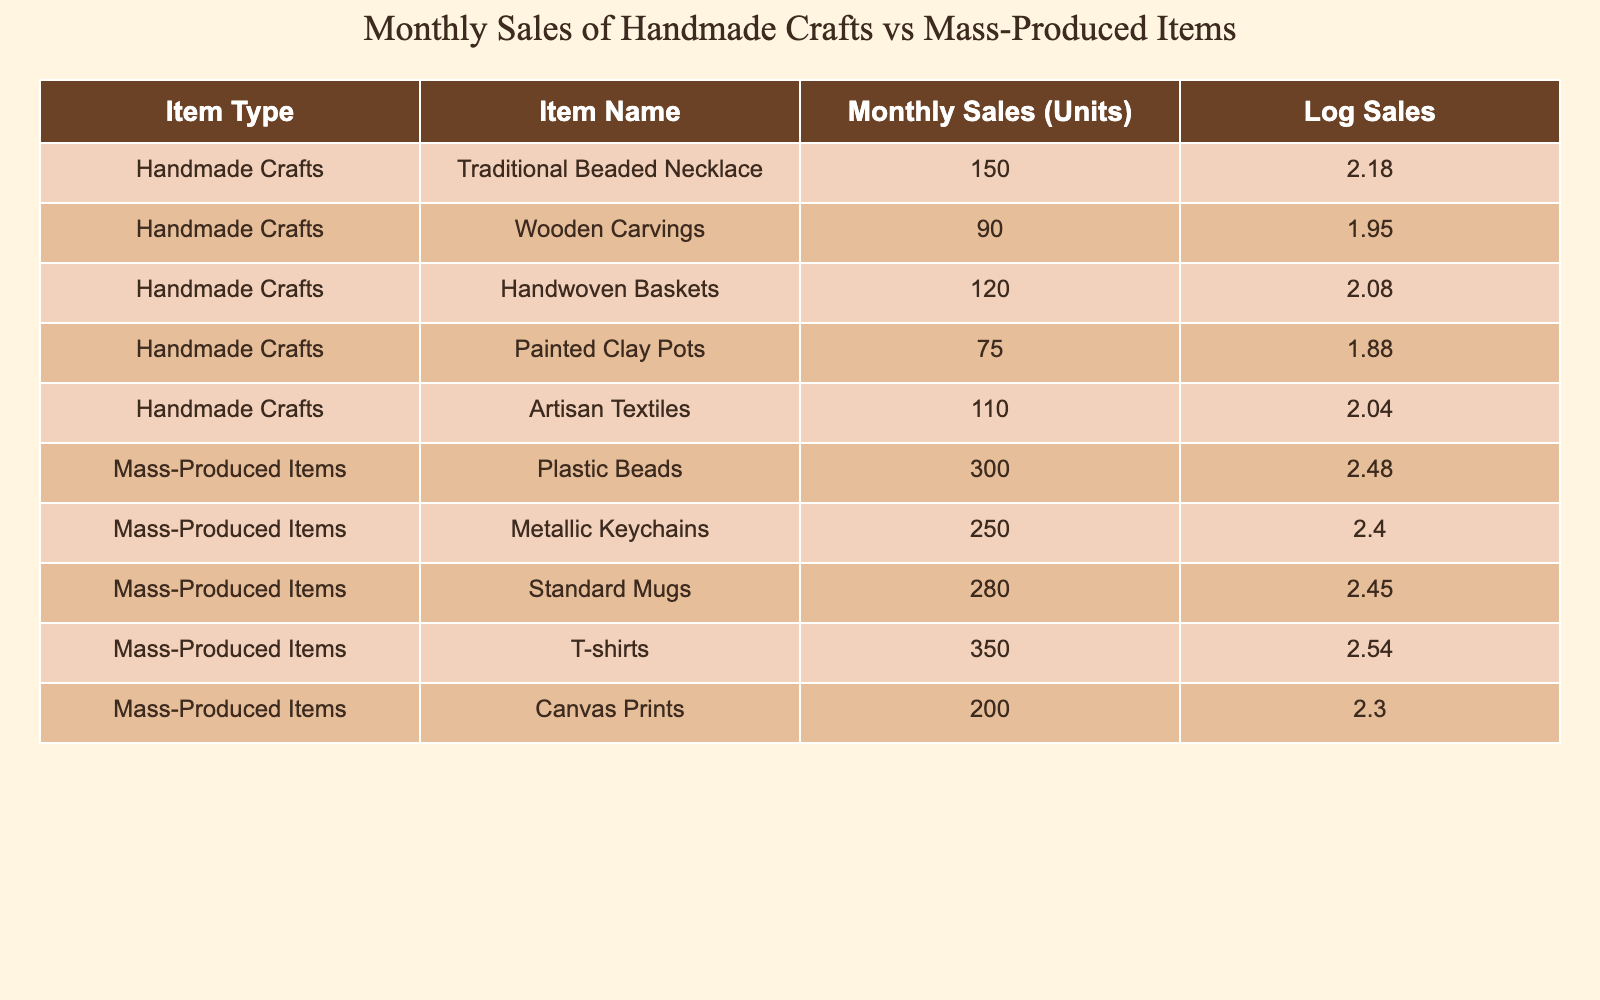What is the monthly sales (units) of the Painted Clay Pots? The table clearly lists the monthly sales for each item. For the Painted Clay Pots, the value is directly shown as 75 in the "Monthly Sales (Units)" column.
Answer: 75 Which item type has the highest monthly sales? To determine the highest sales, we need to compare the total monthly sales for both item types. The handmade crafts sum to 150 + 90 + 120 + 75 + 110 = 545, while mass-produced items sum to 300 + 250 + 280 + 350 + 200 = 1380. Since 1380 (mass-produced items) is greater than 545 (handmade crafts), mass-produced items have the highest sales.
Answer: Mass-produced items What is the difference in monthly sales between the top mass-produced item and the top handmade craft? The top-selling mass-produced item is T-shirts with 350 units, while the top-selling handmade craft is Traditional Beaded Necklace with 150 units. The difference is calculated as 350 - 150 = 200.
Answer: 200 Are more units sold of the Wooden Carvings than the Painted Clay Pots? The monthly sales for Wooden Carvings are 90 units, while for Painted Clay Pots, it is 75 units. Since 90 is greater than 75, it is true that more units of Wooden Carvings are sold.
Answer: Yes What is the average monthly sales of all handmade crafts? To find the average sales of handmade crafts, we first sum their sales: 150 + 90 + 120 + 75 + 110 = 545. Since there are 5 items, the average is 545 / 5 = 109. The average monthly sales for handmade crafts is then 109.
Answer: 109 Which has a higher log sales value, the T-shirts or the Traditional Beaded Necklace? The log sales for T-shirts is calculated as log10(350) which is approximately 2.54, while for Traditional Beaded Necklace it is log10(150) approximately 2.18. Since 2.54 is greater than 2.18, T-shirts have a higher log sales value.
Answer: T-shirts What is the combined monthly sales of all mass-produced items? To calculate the combined sales of mass-produced items, sum all their respective sales: 300 + 250 + 280 + 350 + 200 = 1380. Hence, the combined monthly sales is 1380 units.
Answer: 1380 Is the monthly sales of the Artisan Textiles more than 100? The monthly sales for Artisan Textiles are stated as 110 units. Since 110 is greater than 100, the statement is true.
Answer: Yes Which type of item has a greater median sale value, handmade crafts or mass-produced items? First, we find the median for each group of sales. For handmade crafts (75, 90, 110, 120, 150), the median is 110 (middle value). For mass-produced items (200, 250, 280, 300, 350), the median is 280. Since 280 > 110, mass-produced items have a greater median sale value.
Answer: Mass-produced items 